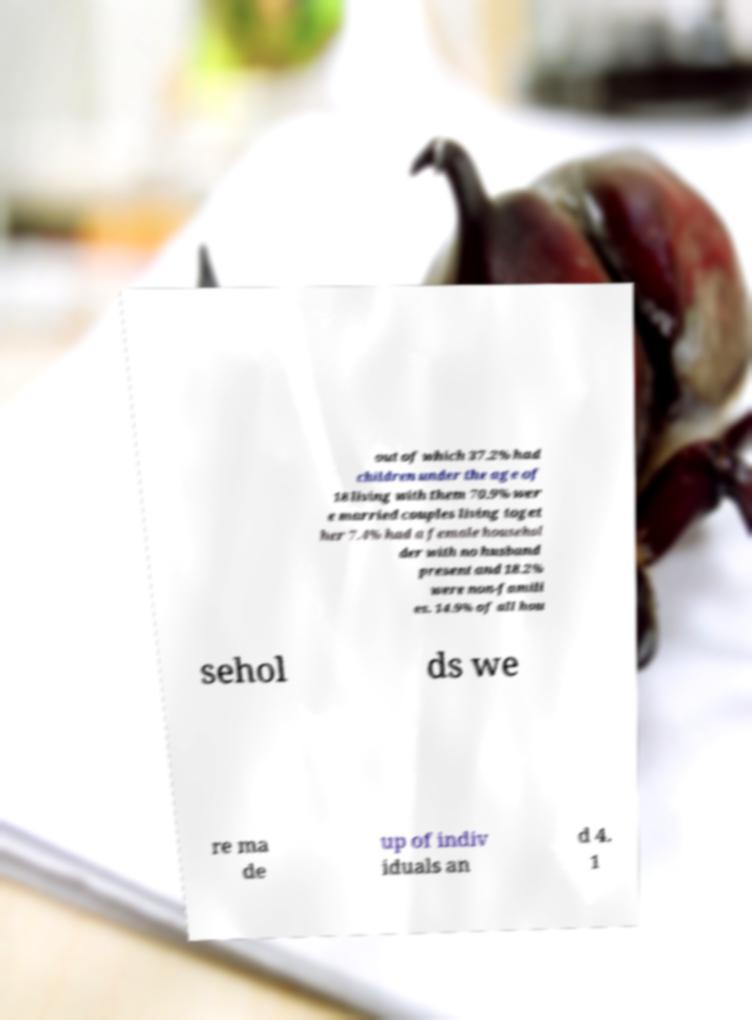For documentation purposes, I need the text within this image transcribed. Could you provide that? out of which 37.2% had children under the age of 18 living with them 70.9% wer e married couples living toget her 7.4% had a female househol der with no husband present and 18.2% were non-famili es. 14.9% of all hou sehol ds we re ma de up of indiv iduals an d 4. 1 